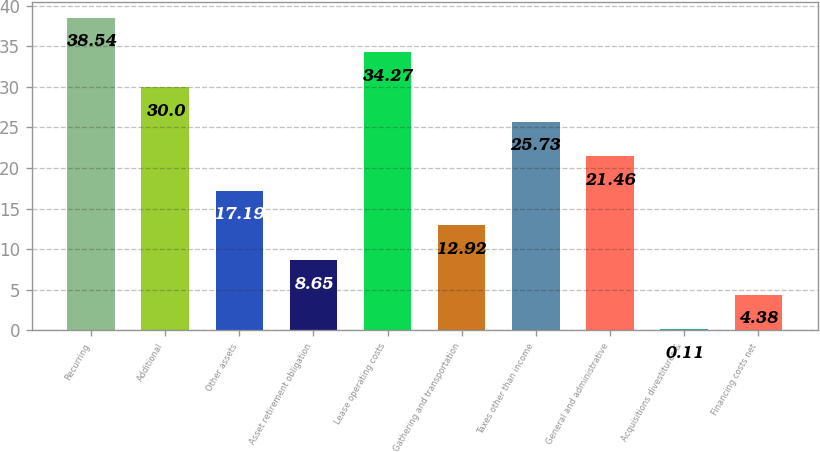Convert chart. <chart><loc_0><loc_0><loc_500><loc_500><bar_chart><fcel>Recurring<fcel>Additional<fcel>Other assets<fcel>Asset retirement obligation<fcel>Lease operating costs<fcel>Gathering and transportation<fcel>Taxes other than income<fcel>General and administrative<fcel>Acquisitions divestitures &<fcel>Financing costs net<nl><fcel>38.54<fcel>30<fcel>17.19<fcel>8.65<fcel>34.27<fcel>12.92<fcel>25.73<fcel>21.46<fcel>0.11<fcel>4.38<nl></chart> 